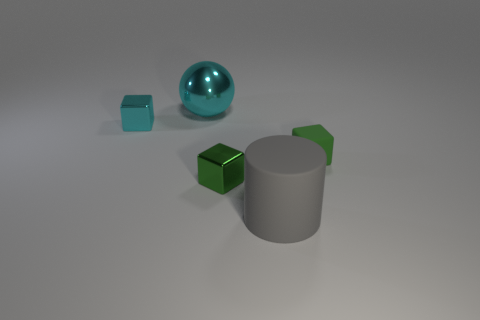Subtract all gray cylinders. How many green cubes are left? 2 Subtract all tiny green cubes. How many cubes are left? 1 Add 5 cubes. How many objects exist? 10 Subtract all balls. How many objects are left? 4 Add 1 blue metal blocks. How many blue metal blocks exist? 1 Subtract 0 blue cylinders. How many objects are left? 5 Subtract all cyan blocks. Subtract all tiny cyan cylinders. How many objects are left? 4 Add 3 large cyan objects. How many large cyan objects are left? 4 